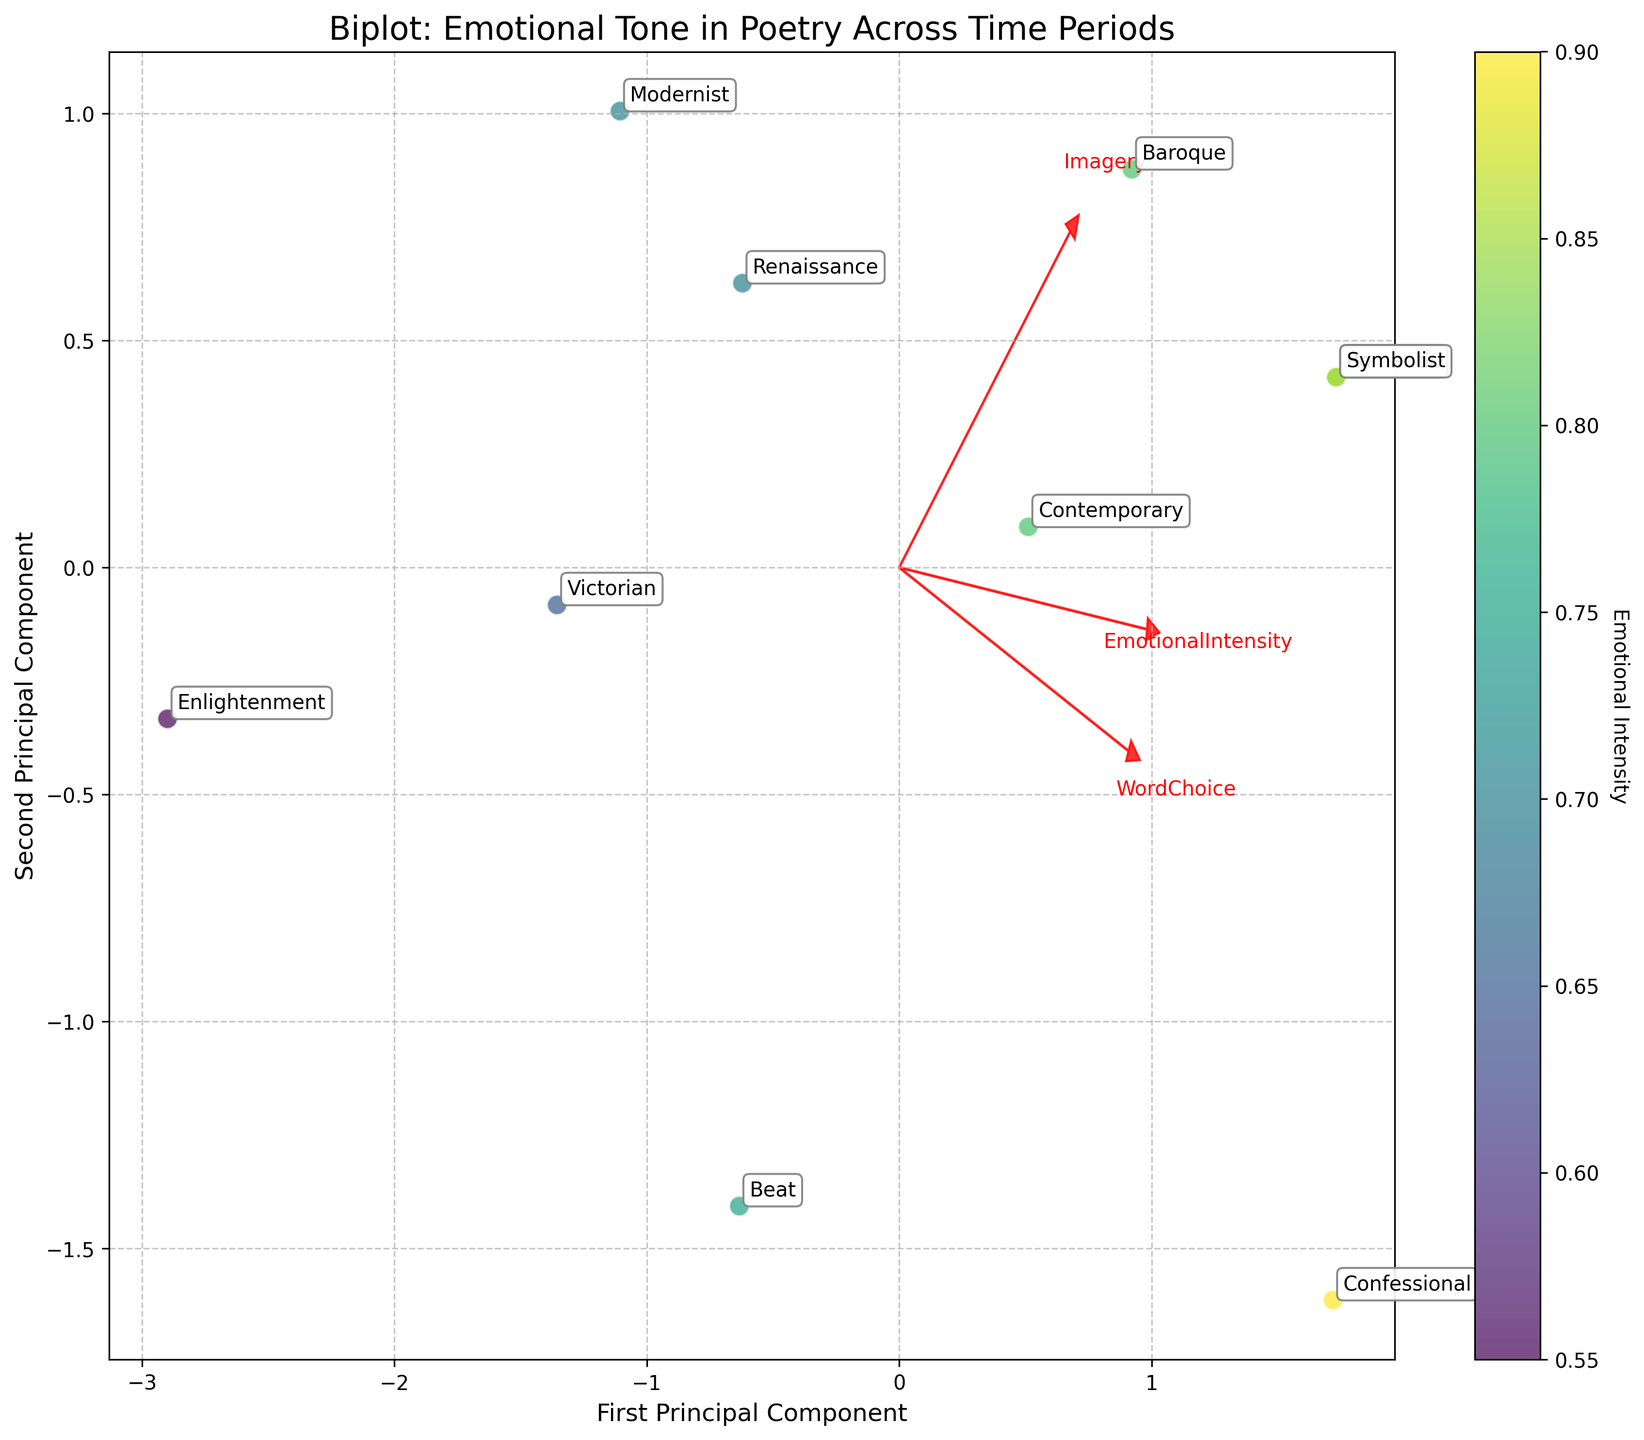What is the title of the biplot? The title is typically located at the top of the plot. It provides a concise summary of the plot's purpose or subject.
Answer: Biplot: Emotional Tone in Poetry Across Time Periods Which period has the highest emotional intensity? Emotional intensity can be identified by the color of the data points. A deeper color (closer to purple/blue) indicates higher emotional intensity. Hover over the data points with the deepest colors to find the period.
Answer: Confessional How many principal components are displayed in the plot? The plot has labeled axes representing principal components. Count the number of labeled axes.
Answer: 2 Which vector points in the direction of the highest correlation with the first principal component? The vector direction can be observed from the arrows plotted in red. Look for the arrow that extends the furthest along the First Principal Component axis.
Answer: WordChoice Which two periods seem to have similar scores on both principal components? Observe the plot for periods that are located closely together in the 2D space, as this proximity suggests similarity in scores on both components.
Answer: Beat and Contemporary Which time period is closer to the vector representing Imagery? Look at the arrow representing Imagery and note the period(s) situated closer to this arrow's direction.
Answer: Romantic Between the Romantic and the Modernist periods, which one has higher word choice scores? WordChoice is one of the vectors. Compare the relative proximity of the Romantic and Modernist periods to the WordChoice arrow.
Answer: Romantic What is the predominant emotion associated with the Renaissance period? Find the label for the Renaissance period and correspondingly match with its predominant emotion from the dataset used to create the plot.
Answer: Love Which principal component has a higher variance explained by the dataset: the first or the second? Principal components' explained variance can be deduced by comparing the lengths of the axes or vectors along each component. Generally, the first component explains a larger variance.
Answer: The first principal component Is the emotional intensity higher for the Beat or the Enlightenment period? Compare the color intensity (as indicated by the colorbar) between the Beat and Enlightenment periods. The period with a deeper color represents higher emotional intensity.
Answer: Beat 